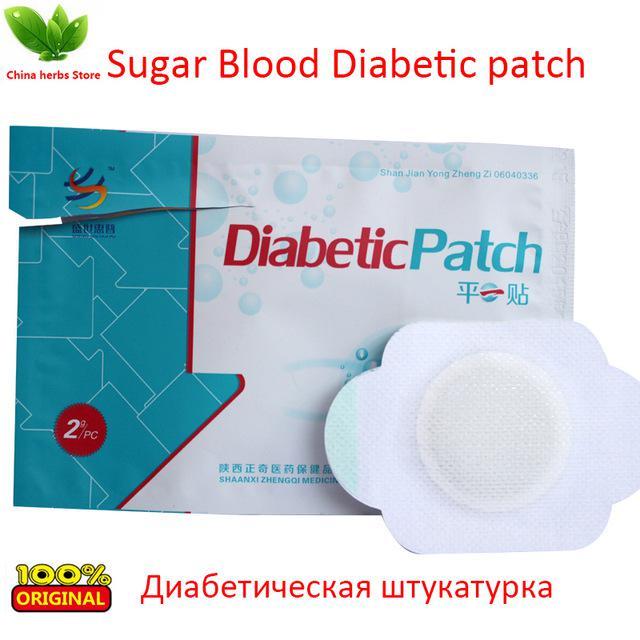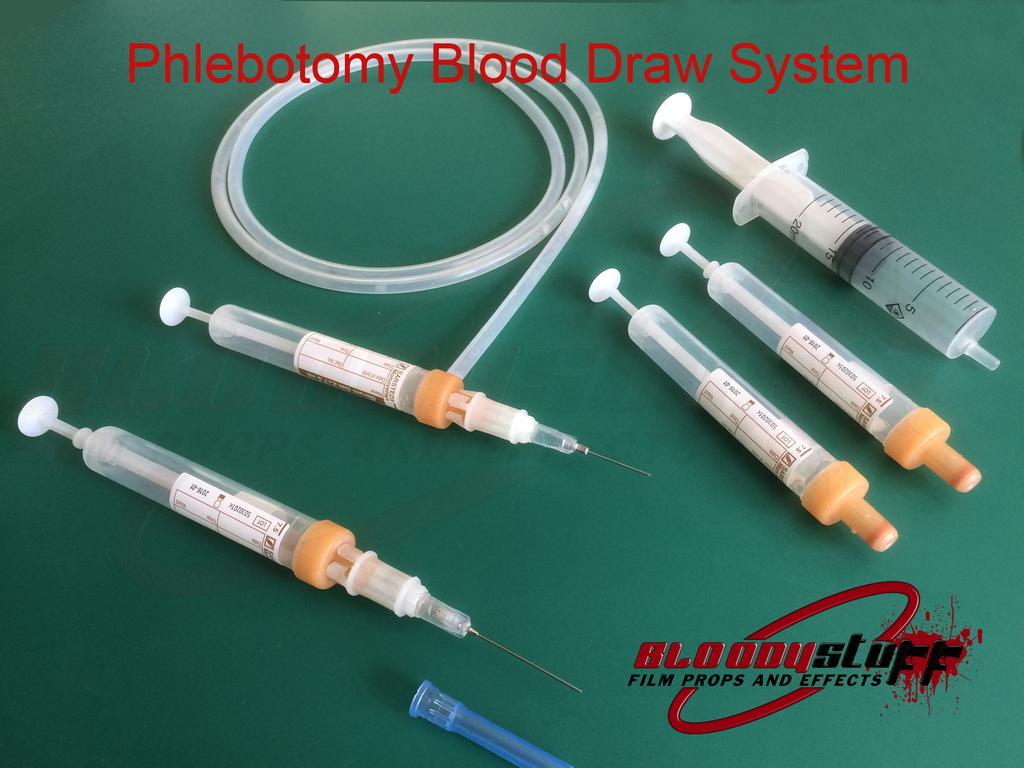The first image is the image on the left, the second image is the image on the right. Evaluate the accuracy of this statement regarding the images: "A human arm is shown next to a medical instrument". Is it true? Answer yes or no. No. The first image is the image on the left, the second image is the image on the right. Given the left and right images, does the statement "there is an arm in the image on the left" hold true? Answer yes or no. No. 